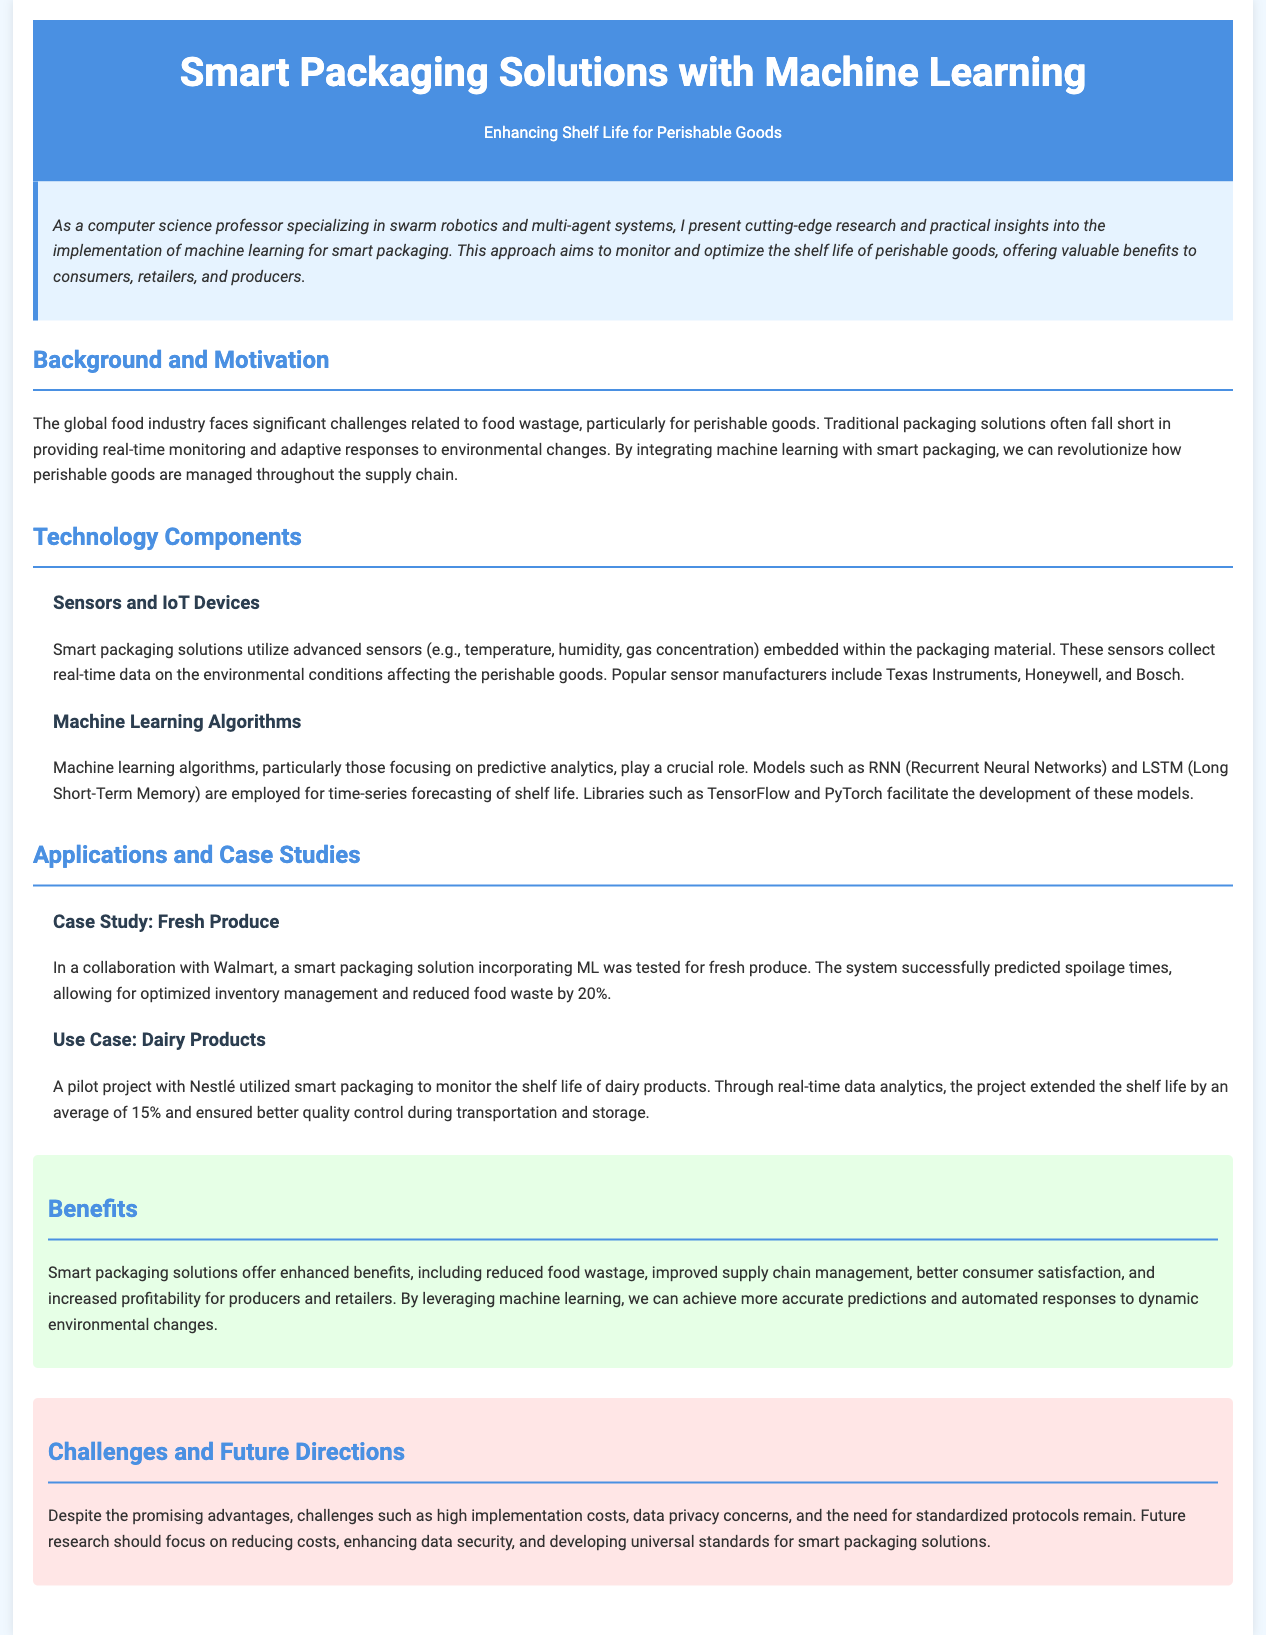What is the title of the document? The title of the document is specified in the document's header.
Answer: Smart Packaging Solutions with Machine Learning What is a key technology used in smart packaging? The document outlines the technology components involved in smart packaging, mentioning specific technologies.
Answer: Sensors and IoT Devices What is the predicted reduction in food waste achieved in the Walmart case study? The case study referenced in the document provides specific results regarding waste reduction.
Answer: 20% Which machine learning algorithm is mentioned for time-series forecasting? The section on Machine Learning Algorithms highlights specific algorithms used in this context.
Answer: LSTM What is one of the main challenges mentioned in the document? The document specifies challenges that smart packaging solutions face, providing a brief list.
Answer: High implementation costs Who collaborated with Nestlé on a smart packaging pilot project? The pilot project section of the document identifies the company involved in the collaboration.
Answer: Nestlé What is one benefit of smart packaging solutions? The Benefits section summarizes the advantages offered by smart packaging solutions.
Answer: Reduced food wastage What aspect of smart packaging should future research focus on? The document discusses future directions and areas where more research is needed, including challenges.
Answer: Enhancing data security 